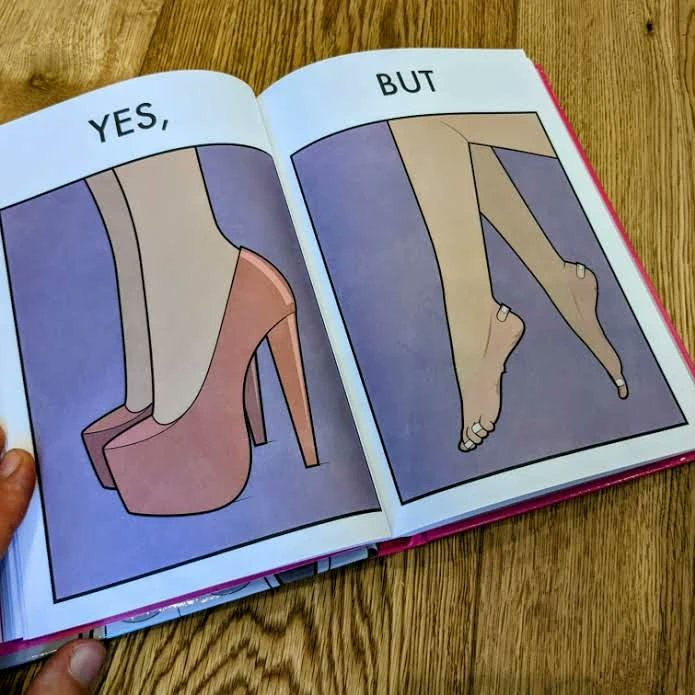Compare the left and right sides of this image. In the left part of the image: a pair of high heeled shoes In the right part of the image: A pair of feet, blistered and red, with bandages 